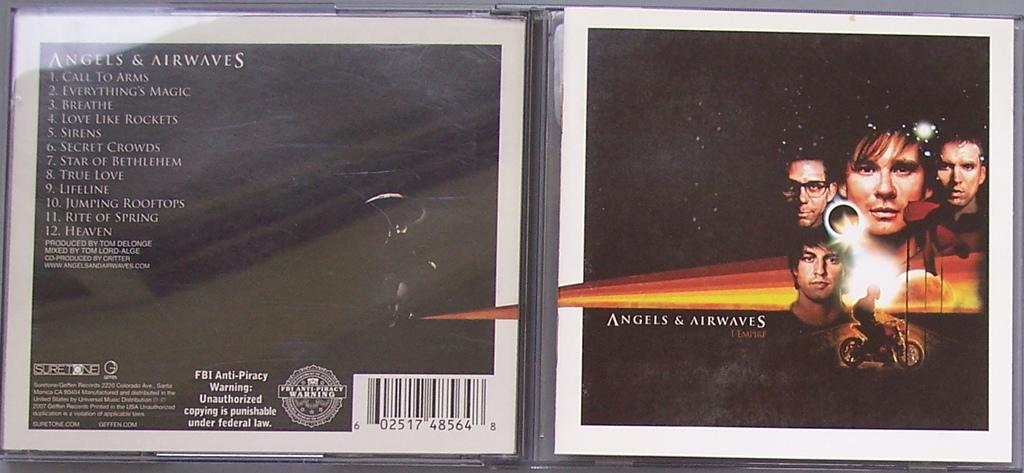<image>
Write a terse but informative summary of the picture. Album cover for Angels & Airways as well as the tracklistings. 